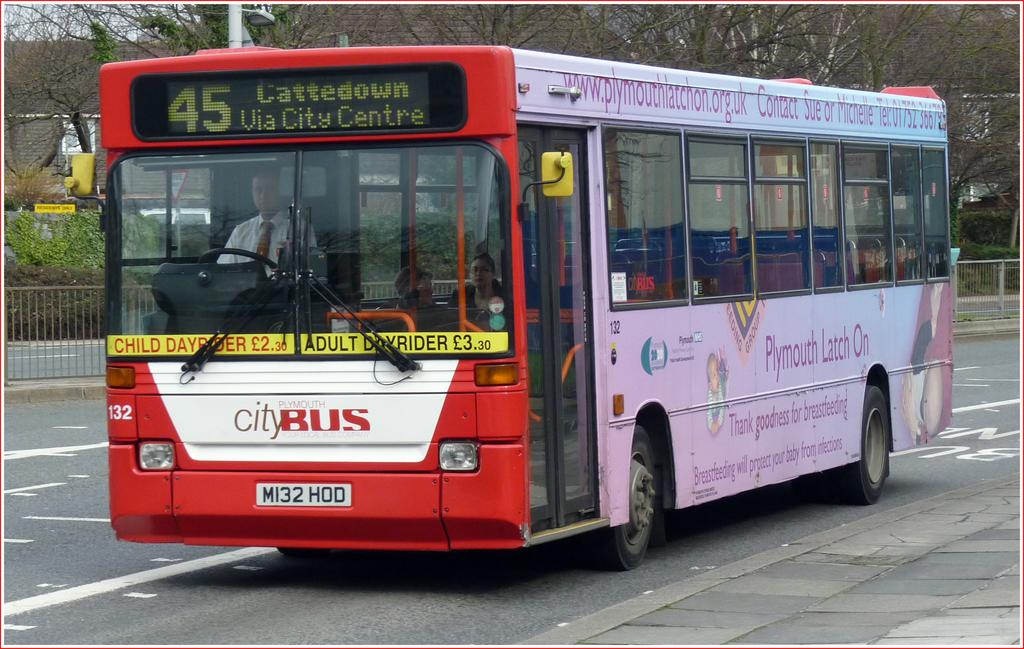<image>
Give a short and clear explanation of the subsequent image. a city bus that is red and also white 